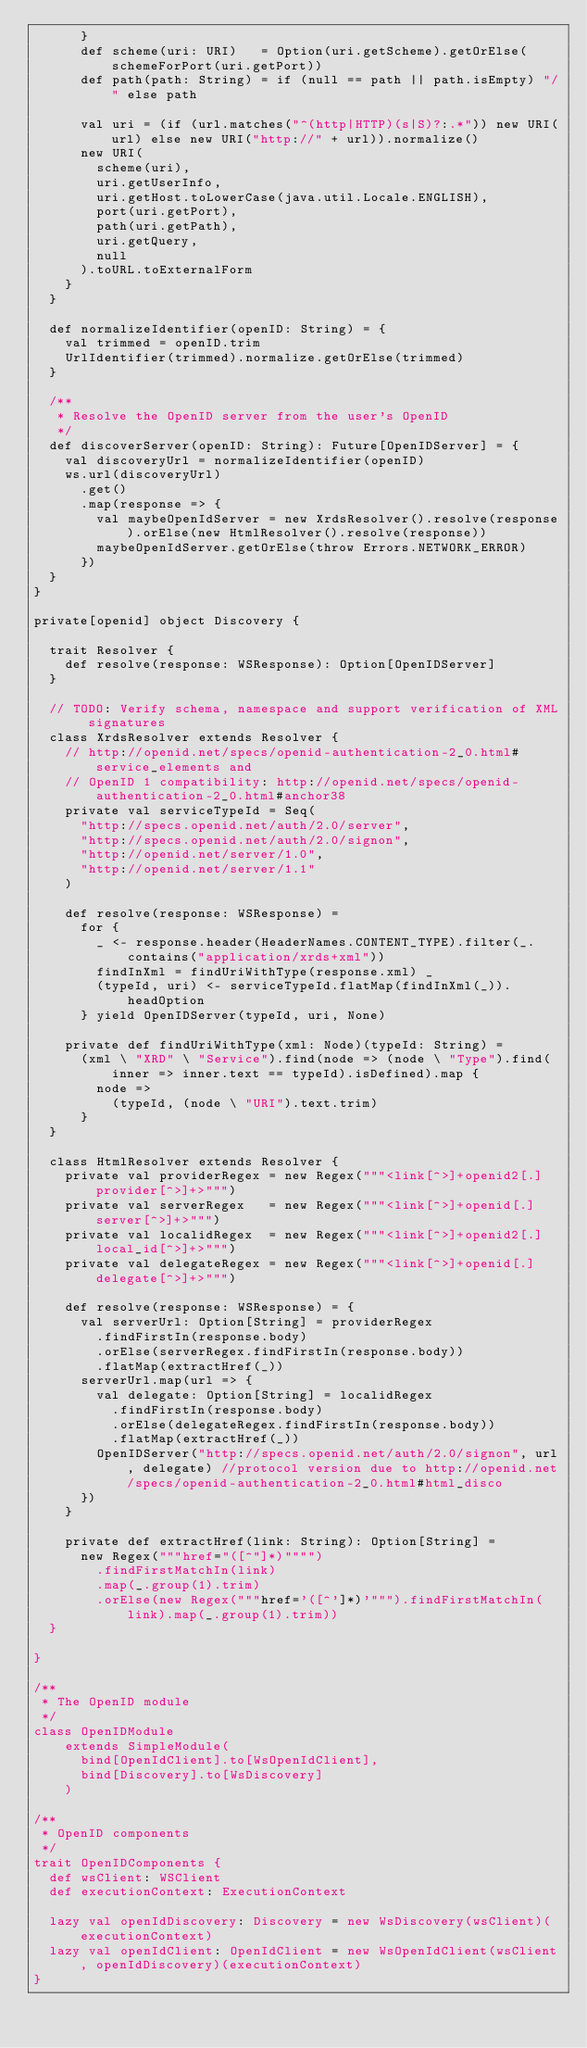Convert code to text. <code><loc_0><loc_0><loc_500><loc_500><_Scala_>      }
      def scheme(uri: URI)   = Option(uri.getScheme).getOrElse(schemeForPort(uri.getPort))
      def path(path: String) = if (null == path || path.isEmpty) "/" else path

      val uri = (if (url.matches("^(http|HTTP)(s|S)?:.*")) new URI(url) else new URI("http://" + url)).normalize()
      new URI(
        scheme(uri),
        uri.getUserInfo,
        uri.getHost.toLowerCase(java.util.Locale.ENGLISH),
        port(uri.getPort),
        path(uri.getPath),
        uri.getQuery,
        null
      ).toURL.toExternalForm
    }
  }

  def normalizeIdentifier(openID: String) = {
    val trimmed = openID.trim
    UrlIdentifier(trimmed).normalize.getOrElse(trimmed)
  }

  /**
   * Resolve the OpenID server from the user's OpenID
   */
  def discoverServer(openID: String): Future[OpenIDServer] = {
    val discoveryUrl = normalizeIdentifier(openID)
    ws.url(discoveryUrl)
      .get()
      .map(response => {
        val maybeOpenIdServer = new XrdsResolver().resolve(response).orElse(new HtmlResolver().resolve(response))
        maybeOpenIdServer.getOrElse(throw Errors.NETWORK_ERROR)
      })
  }
}

private[openid] object Discovery {

  trait Resolver {
    def resolve(response: WSResponse): Option[OpenIDServer]
  }

  // TODO: Verify schema, namespace and support verification of XML signatures
  class XrdsResolver extends Resolver {
    // http://openid.net/specs/openid-authentication-2_0.html#service_elements and
    // OpenID 1 compatibility: http://openid.net/specs/openid-authentication-2_0.html#anchor38
    private val serviceTypeId = Seq(
      "http://specs.openid.net/auth/2.0/server",
      "http://specs.openid.net/auth/2.0/signon",
      "http://openid.net/server/1.0",
      "http://openid.net/server/1.1"
    )

    def resolve(response: WSResponse) =
      for {
        _ <- response.header(HeaderNames.CONTENT_TYPE).filter(_.contains("application/xrds+xml"))
        findInXml = findUriWithType(response.xml) _
        (typeId, uri) <- serviceTypeId.flatMap(findInXml(_)).headOption
      } yield OpenIDServer(typeId, uri, None)

    private def findUriWithType(xml: Node)(typeId: String) =
      (xml \ "XRD" \ "Service").find(node => (node \ "Type").find(inner => inner.text == typeId).isDefined).map {
        node =>
          (typeId, (node \ "URI").text.trim)
      }
  }

  class HtmlResolver extends Resolver {
    private val providerRegex = new Regex("""<link[^>]+openid2[.]provider[^>]+>""")
    private val serverRegex   = new Regex("""<link[^>]+openid[.]server[^>]+>""")
    private val localidRegex  = new Regex("""<link[^>]+openid2[.]local_id[^>]+>""")
    private val delegateRegex = new Regex("""<link[^>]+openid[.]delegate[^>]+>""")

    def resolve(response: WSResponse) = {
      val serverUrl: Option[String] = providerRegex
        .findFirstIn(response.body)
        .orElse(serverRegex.findFirstIn(response.body))
        .flatMap(extractHref(_))
      serverUrl.map(url => {
        val delegate: Option[String] = localidRegex
          .findFirstIn(response.body)
          .orElse(delegateRegex.findFirstIn(response.body))
          .flatMap(extractHref(_))
        OpenIDServer("http://specs.openid.net/auth/2.0/signon", url, delegate) //protocol version due to http://openid.net/specs/openid-authentication-2_0.html#html_disco
      })
    }

    private def extractHref(link: String): Option[String] =
      new Regex("""href="([^"]*)"""")
        .findFirstMatchIn(link)
        .map(_.group(1).trim)
        .orElse(new Regex("""href='([^']*)'""").findFirstMatchIn(link).map(_.group(1).trim))
  }

}

/**
 * The OpenID module
 */
class OpenIDModule
    extends SimpleModule(
      bind[OpenIdClient].to[WsOpenIdClient],
      bind[Discovery].to[WsDiscovery]
    )

/**
 * OpenID components
 */
trait OpenIDComponents {
  def wsClient: WSClient
  def executionContext: ExecutionContext

  lazy val openIdDiscovery: Discovery = new WsDiscovery(wsClient)(executionContext)
  lazy val openIdClient: OpenIdClient = new WsOpenIdClient(wsClient, openIdDiscovery)(executionContext)
}
</code> 